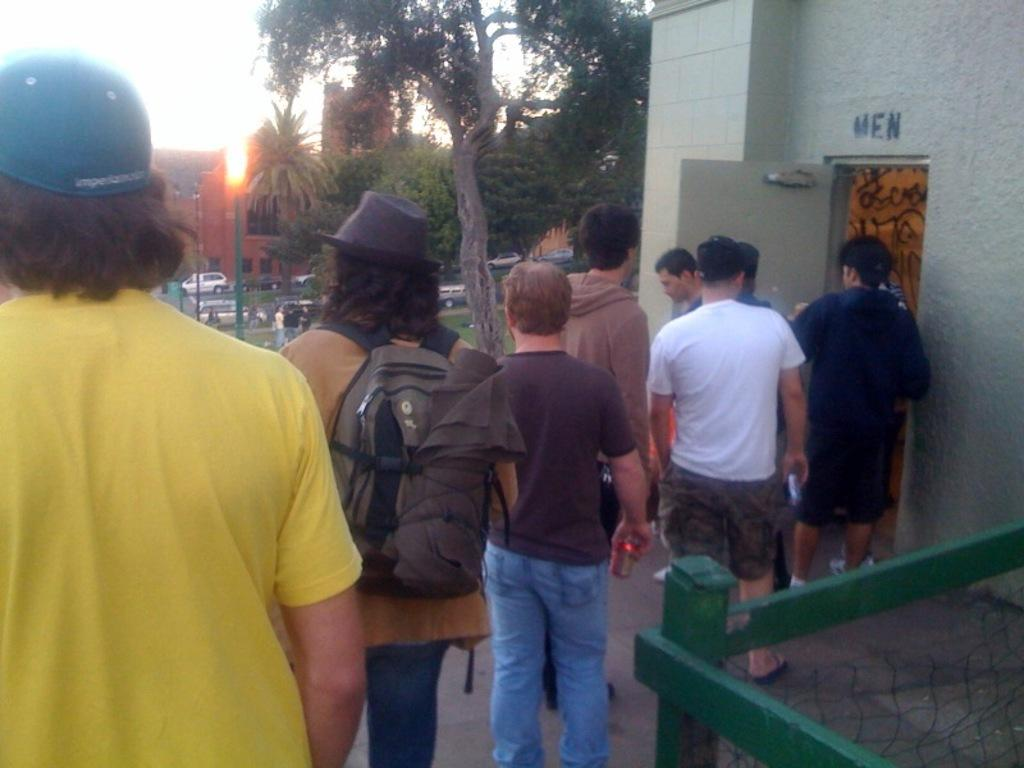How many people are in the image? There is a group of people in the image, but the exact number is not specified. What are the people doing in the image? The people are standing on the floor in the image. What is the purpose of the net in the image? The purpose of the net is not specified in the facts provided. What is inside the bag in the image? The contents of the bag are not specified in the facts provided. What type of buildings can be seen in the image? The type of buildings is not specified in the facts provided. What type of trees are in the image? The type of trees is not specified in the facts provided. What type of vehicles are in the image? The type of vehicles is not specified in the facts provided. What are the poles used for in the image? The purpose of the poles is not specified in the facts provided. What are the unspecified objects in the image? The unspecified objects are not described in the facts provided. What can be seen in the background of the image? The sky is visible in the background of the image. How many turkeys are sleeping on the poles in the image? There are no turkeys or sleeping animals present in the image. What type of iron is being used to hold the bag in the image? There is no iron present in the image, and the bag is not being held by any visible object. 